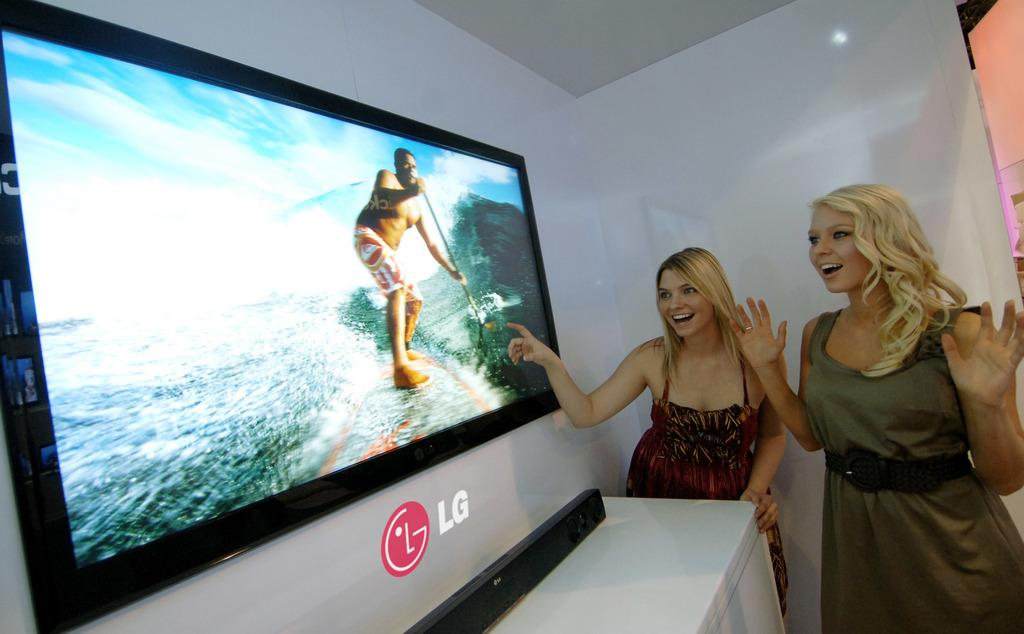Provide a one-sentence caption for the provided image. Two blonde women looking at an LG screen that is on the wall. 